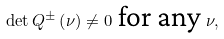Convert formula to latex. <formula><loc_0><loc_0><loc_500><loc_500>\det Q ^ { \pm } \left ( \nu \right ) \neq 0 \text { for any } \nu ,</formula> 